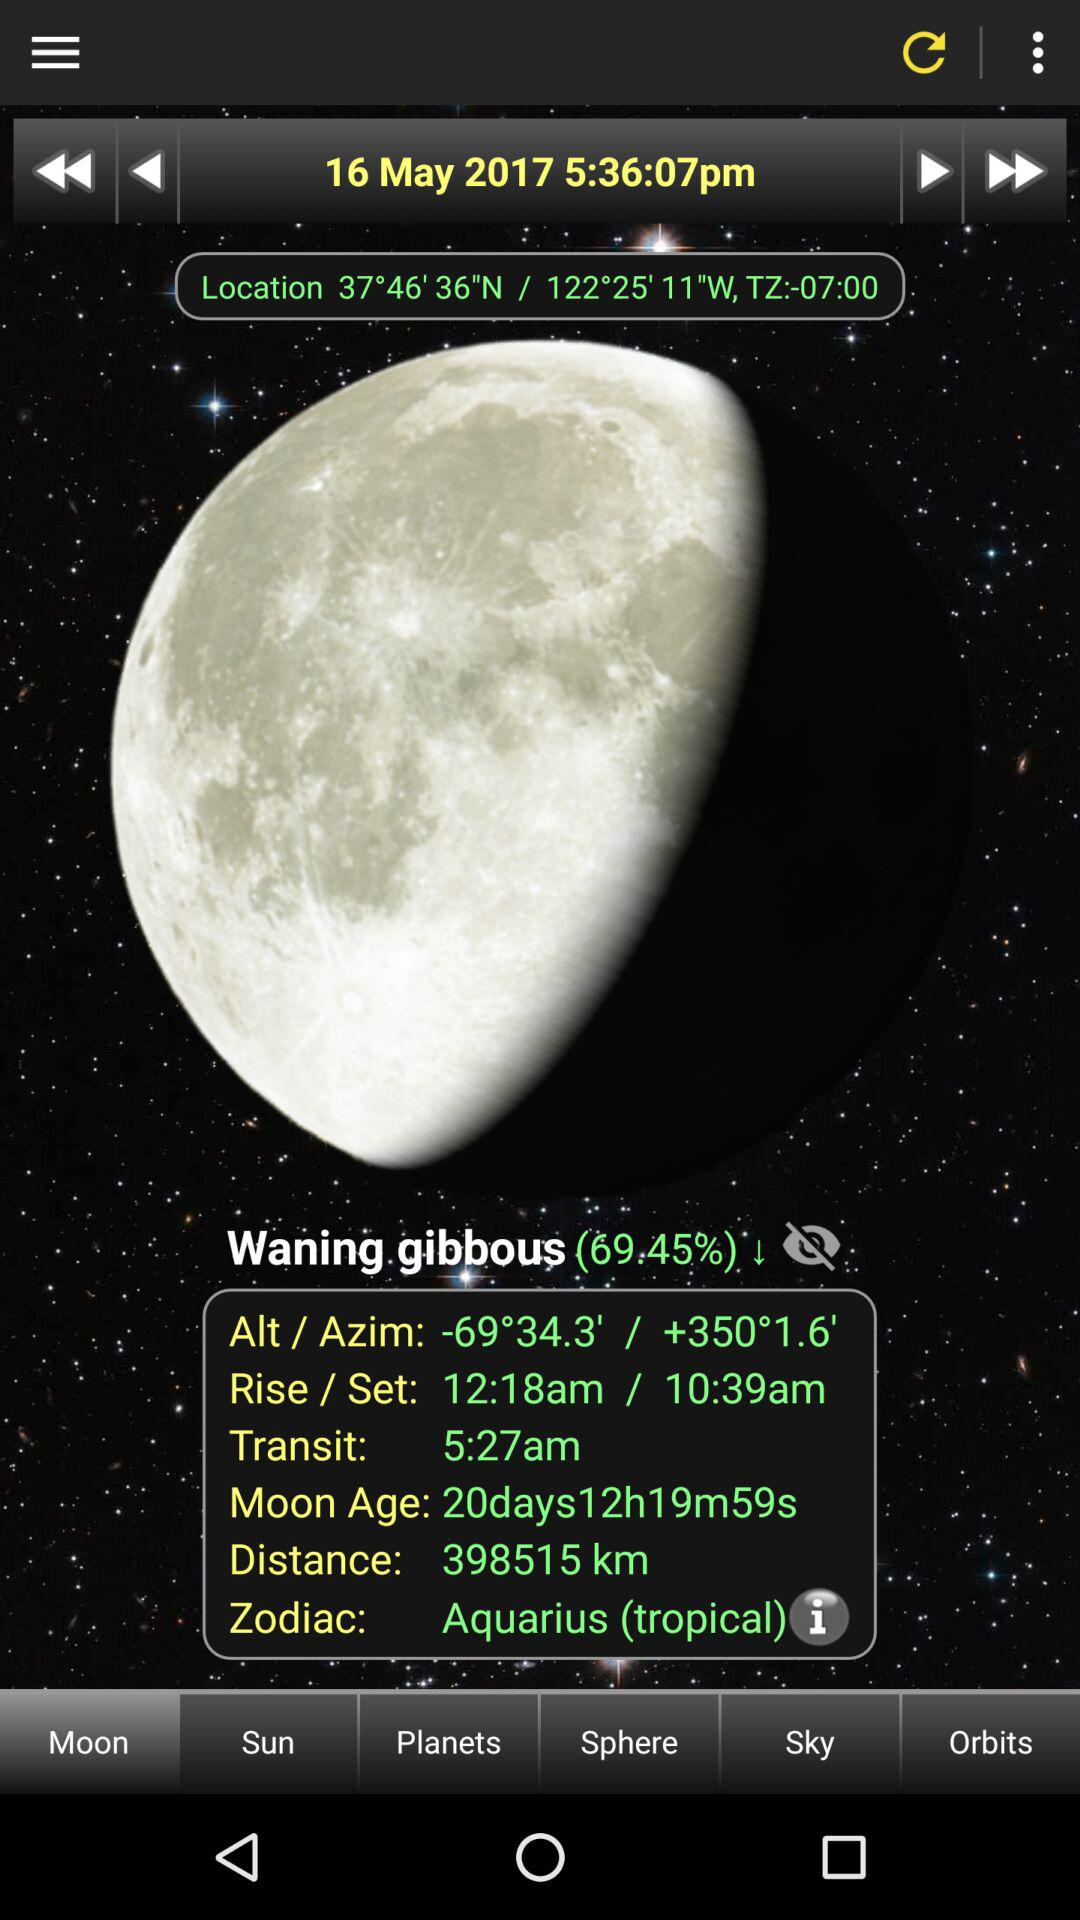What are the rising and setting times? The rising time is 12:18 a.m. and the setting time is 10:39 a.m. 